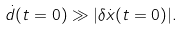Convert formula to latex. <formula><loc_0><loc_0><loc_500><loc_500>\dot { d } ( t = 0 ) \gg | \delta \dot { x } ( t = 0 ) | .</formula> 